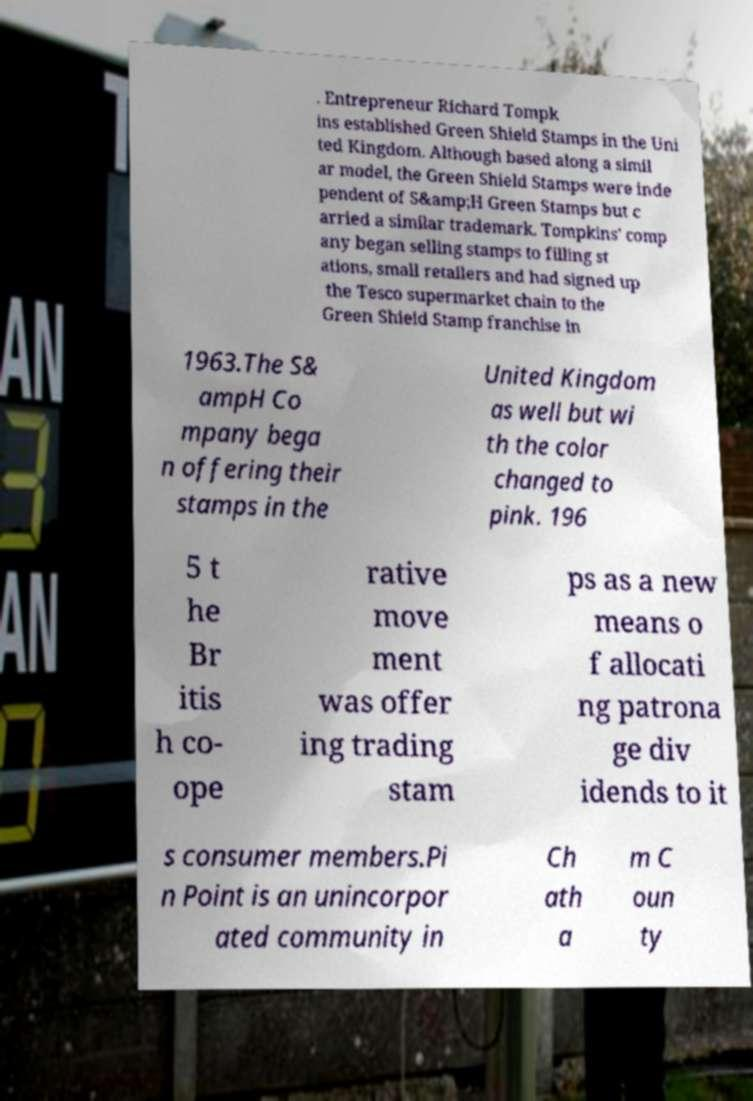Can you accurately transcribe the text from the provided image for me? . Entrepreneur Richard Tompk ins established Green Shield Stamps in the Uni ted Kingdom. Although based along a simil ar model, the Green Shield Stamps were inde pendent of S&amp;H Green Stamps but c arried a similar trademark. Tompkins' comp any began selling stamps to filling st ations, small retailers and had signed up the Tesco supermarket chain to the Green Shield Stamp franchise in 1963.The S& ampH Co mpany bega n offering their stamps in the United Kingdom as well but wi th the color changed to pink. 196 5 t he Br itis h co- ope rative move ment was offer ing trading stam ps as a new means o f allocati ng patrona ge div idends to it s consumer members.Pi n Point is an unincorpor ated community in Ch ath a m C oun ty 